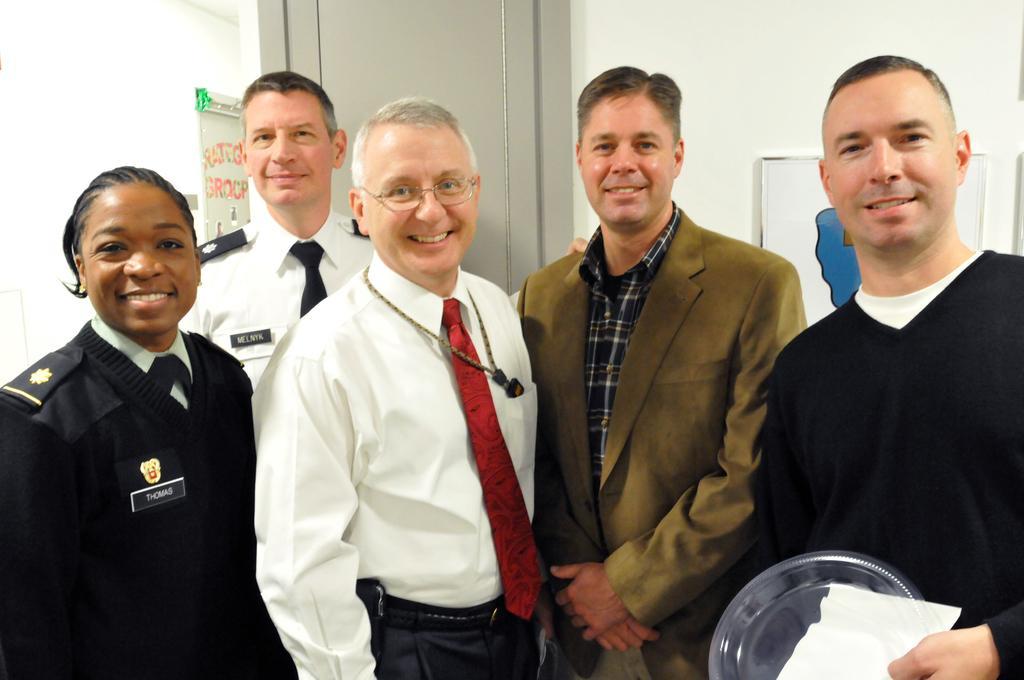How would you summarize this image in a sentence or two? In this picture we can see a group of people standing. A man is holding some objects. Behind the people, there is a door, wall and some objects. 